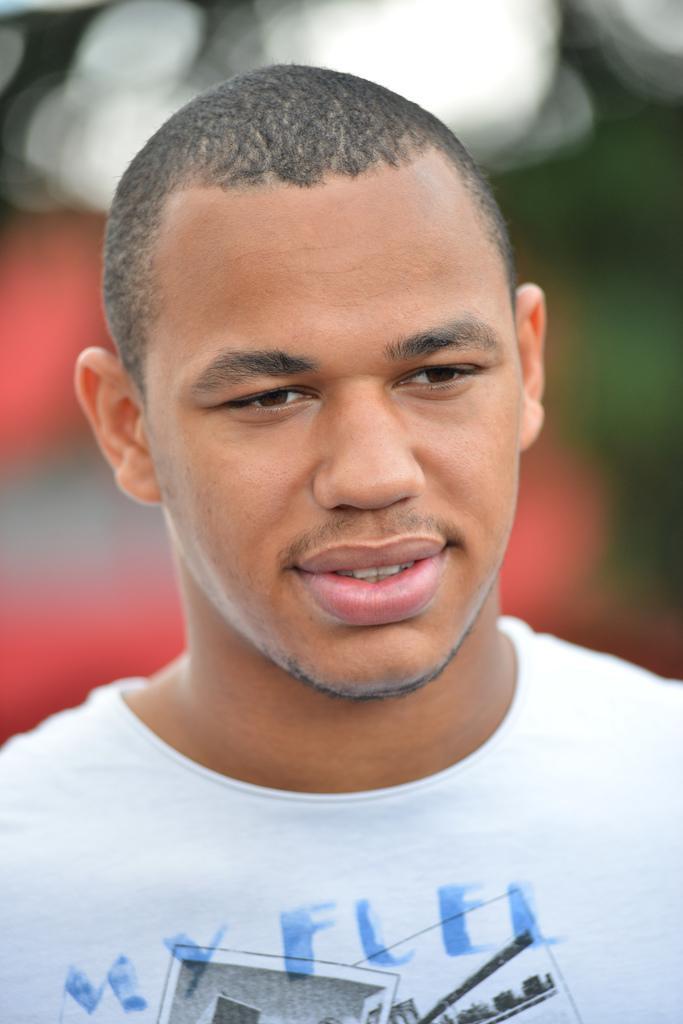Could you give a brief overview of what you see in this image? In this image we can see a person with white shirt is posing for a picture. 